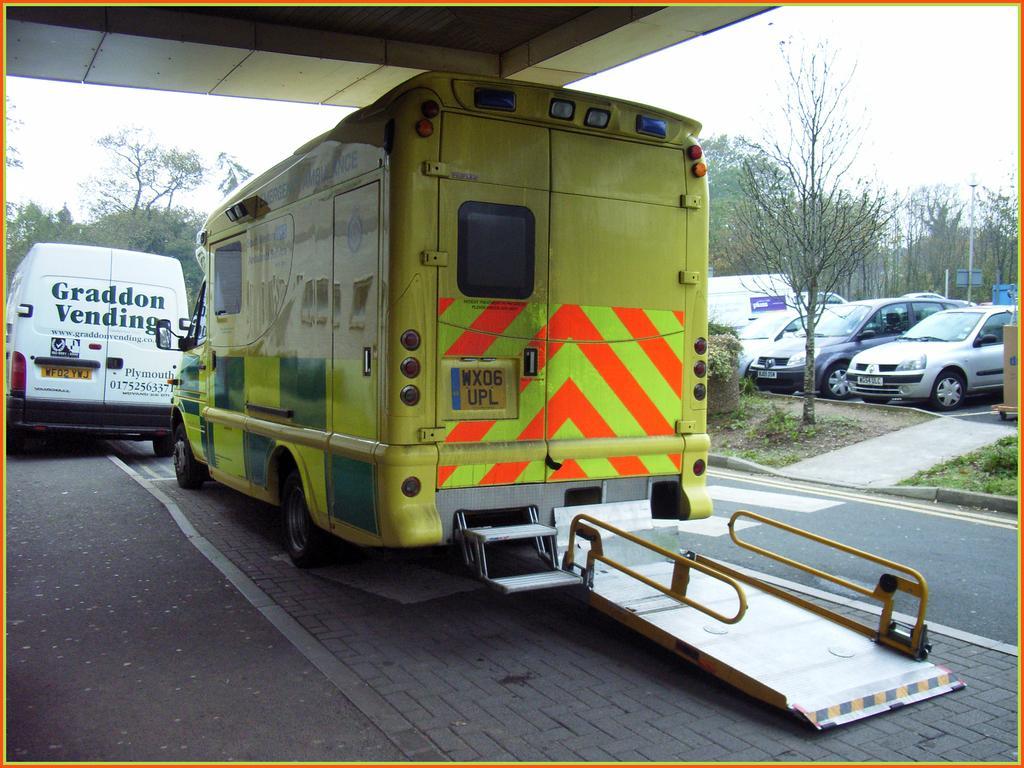Please provide a concise description of this image. In this image, we can see some vehicles. There are trees in the middle of the image. There is a ceiling and sky at the top of the image. 